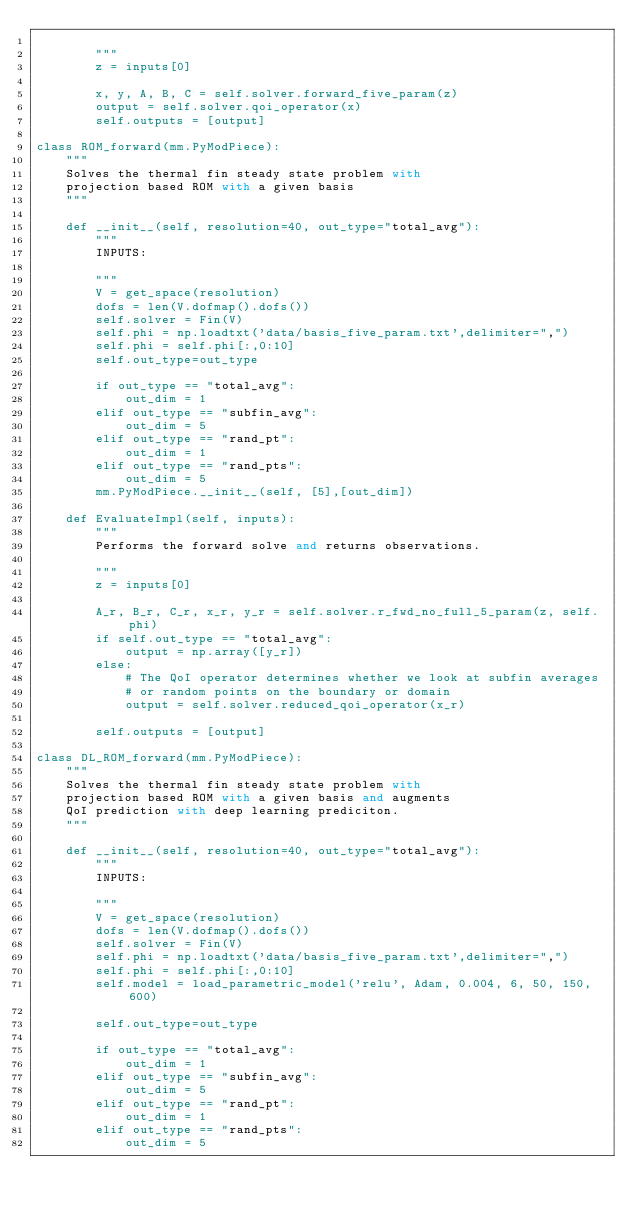Convert code to text. <code><loc_0><loc_0><loc_500><loc_500><_Python_>        
        """
        z = inputs[0]

        x, y, A, B, C = self.solver.forward_five_param(z)
        output = self.solver.qoi_operator(x)
        self.outputs = [output]

class ROM_forward(mm.PyModPiece):
    """
    Solves the thermal fin steady state problem with 
    projection based ROM with a given basis
    """
    
    def __init__(self, resolution=40, out_type="total_avg"):
        """ 
        INPUTS:
     
        """
        V = get_space(resolution)
        dofs = len(V.dofmap().dofs())
        self.solver = Fin(V)
        self.phi = np.loadtxt('data/basis_five_param.txt',delimiter=",")
        self.phi = self.phi[:,0:10]
        self.out_type=out_type

        if out_type == "total_avg":
            out_dim = 1
        elif out_type == "subfin_avg":
            out_dim = 5
        elif out_type == "rand_pt":
            out_dim = 1
        elif out_type == "rand_pts":
            out_dim = 5
        mm.PyModPiece.__init__(self, [5],[out_dim])
            
    def EvaluateImpl(self, inputs):
        """
        Performs the forward solve and returns observations.
        
        """
        z = inputs[0]

        A_r, B_r, C_r, x_r, y_r = self.solver.r_fwd_no_full_5_param(z, self.phi)
        if self.out_type == "total_avg":
            output = np.array([y_r])
        else:
            # The QoI operator determines whether we look at subfin averages
            # or random points on the boundary or domain
            output = self.solver.reduced_qoi_operator(x_r)
        
        self.outputs = [output]

class DL_ROM_forward(mm.PyModPiece):
    """
    Solves the thermal fin steady state problem with 
    projection based ROM with a given basis and augments
    QoI prediction with deep learning prediciton.
    """
    
    def __init__(self, resolution=40, out_type="total_avg"):
        """ 
        INPUTS:
     
        """
        V = get_space(resolution)
        dofs = len(V.dofmap().dofs())
        self.solver = Fin(V)
        self.phi = np.loadtxt('data/basis_five_param.txt',delimiter=",")
        self.phi = self.phi[:,0:10]
        self.model = load_parametric_model('relu', Adam, 0.004, 6, 50, 150, 600)

        self.out_type=out_type

        if out_type == "total_avg":
            out_dim = 1
        elif out_type == "subfin_avg":
            out_dim = 5
        elif out_type == "rand_pt":
            out_dim = 1
        elif out_type == "rand_pts":
            out_dim = 5</code> 